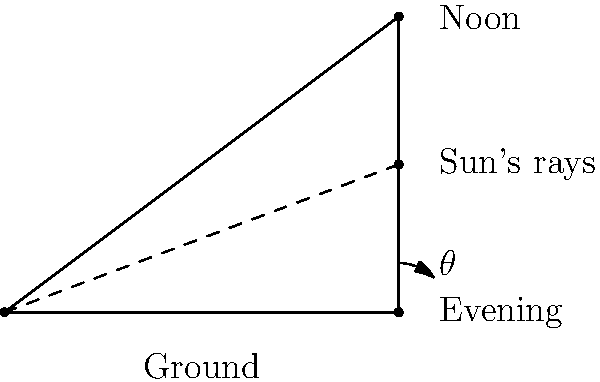As you plan shade structures for a new nature trail, you need to consider the angle formed by the sun's rays and the ground at different times of day. If the angle $\theta$ between the sun's rays and the ground is 45° in the evening, what is the ratio of the height of a vertical post to the length of its shadow at that time? Let's approach this step-by-step:

1) In the diagram, we can see a right triangle formed by the ground, the sun's rays, and an imaginary vertical line (which could represent our post).

2) The angle $\theta$ between the sun's rays and the ground is given as 45°.

3) In a right triangle, the tangent of an angle is the ratio of the opposite side to the adjacent side.

4) In this case:
   - The height of the post is the opposite side to angle $\theta$
   - The length of the shadow is the adjacent side to angle $\theta$

5) We can express this mathematically as:

   $\tan(\theta) = \frac{\text{height of post}}{\text{length of shadow}}$

6) We know that $\theta = 45°$, and $\tan(45°) = 1$

7) Therefore:

   $1 = \frac{\text{height of post}}{\text{length of shadow}}$

8) This means that the height of the post is equal to the length of its shadow.

9) The ratio of height to shadow length is thus 1:1, or simply 1.
Answer: 1 